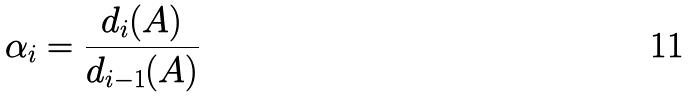<formula> <loc_0><loc_0><loc_500><loc_500>\alpha _ { i } = \frac { d _ { i } ( A ) } { d _ { i - 1 } ( A ) }</formula> 